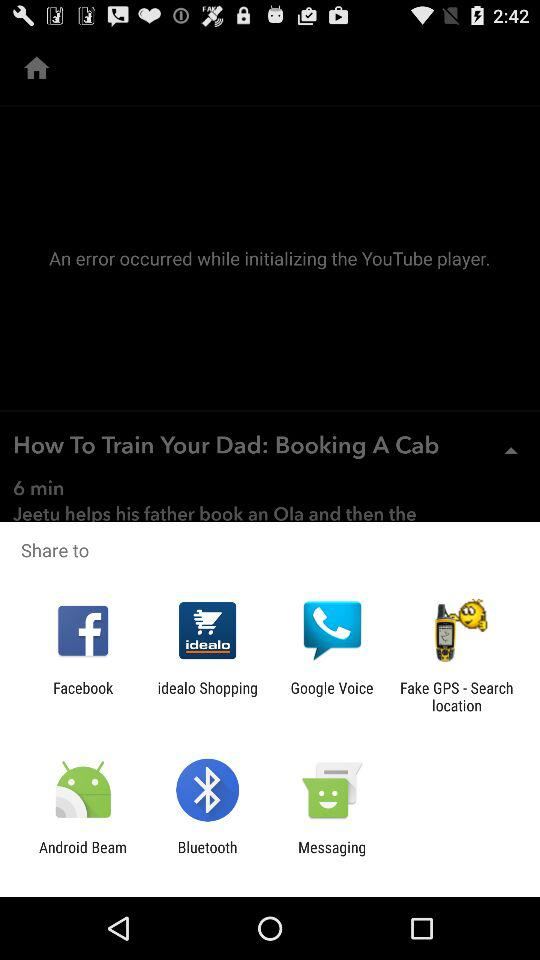When has the error occurred? The error occurred while initializing the "YouTube" player. 